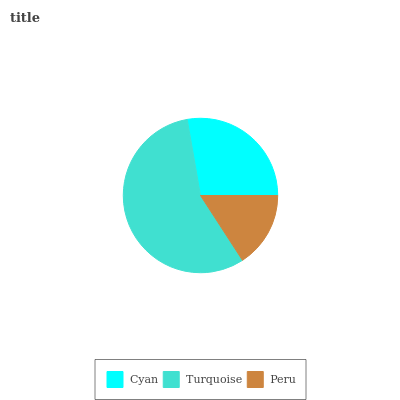Is Peru the minimum?
Answer yes or no. Yes. Is Turquoise the maximum?
Answer yes or no. Yes. Is Turquoise the minimum?
Answer yes or no. No. Is Peru the maximum?
Answer yes or no. No. Is Turquoise greater than Peru?
Answer yes or no. Yes. Is Peru less than Turquoise?
Answer yes or no. Yes. Is Peru greater than Turquoise?
Answer yes or no. No. Is Turquoise less than Peru?
Answer yes or no. No. Is Cyan the high median?
Answer yes or no. Yes. Is Cyan the low median?
Answer yes or no. Yes. Is Peru the high median?
Answer yes or no. No. Is Peru the low median?
Answer yes or no. No. 